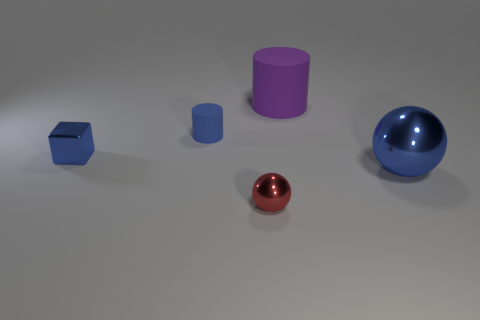If these objects were part of a set, what kind of theme would that set likely have? Given their simple geometric shapes and consistent color palette, the set could belong to a minimalist or educational theme, perhaps used for teaching shapes, sizes, and spatial relations. 